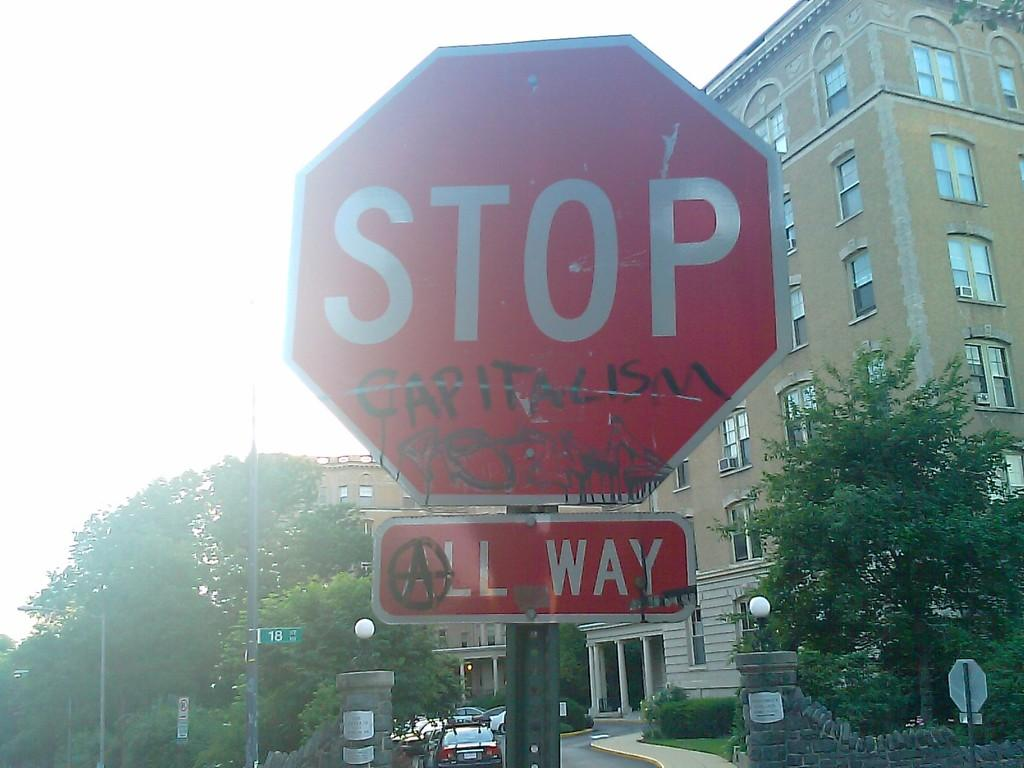<image>
Present a compact description of the photo's key features. A stop sign near 18th street has been vandalized to read "Stop capitalism". 